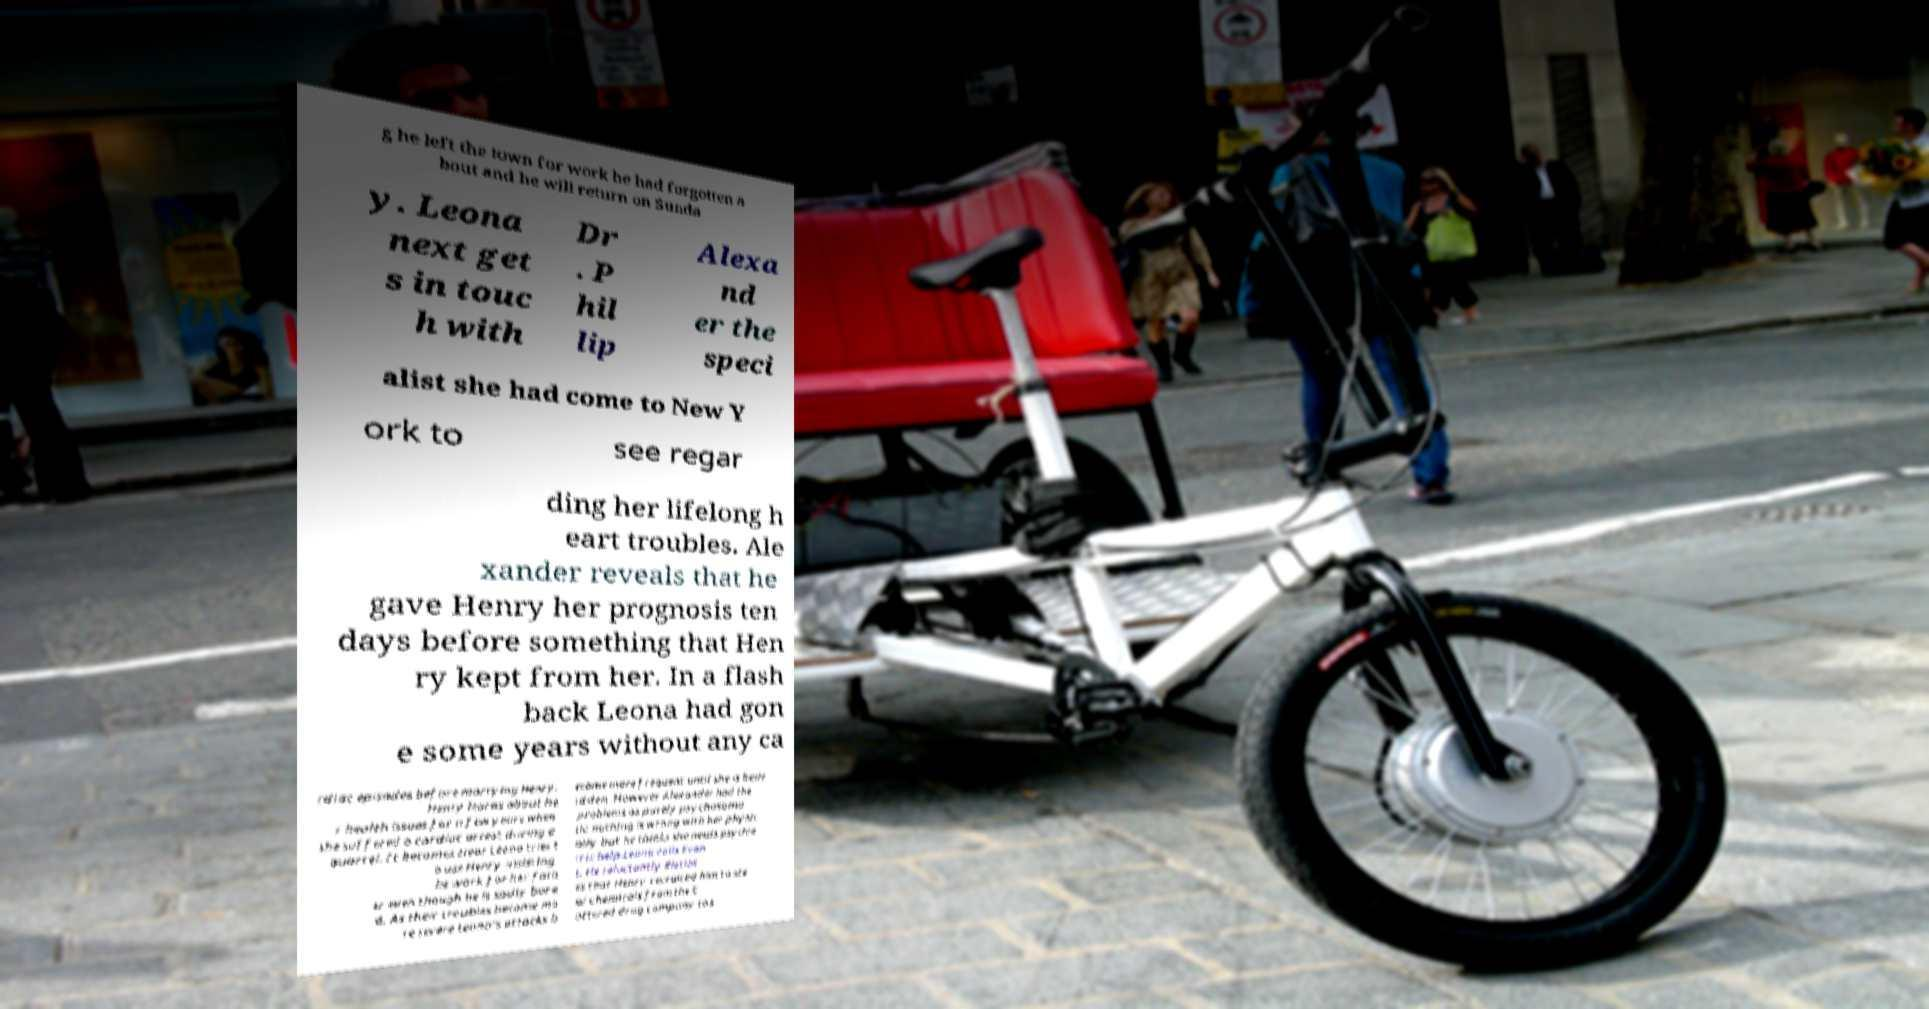Can you read and provide the text displayed in the image?This photo seems to have some interesting text. Can you extract and type it out for me? g he left the town for work he had forgotten a bout and he will return on Sunda y. Leona next get s in touc h with Dr . P hil lip Alexa nd er the speci alist she had come to New Y ork to see regar ding her lifelong h eart troubles. Ale xander reveals that he gave Henry her prognosis ten days before something that Hen ry kept from her. In a flash back Leona had gon e some years without any ca rdiac episodes before marrying Henry. Henry learns about he r health issues for a few years when she suffered a cardiac arrest during a quarrel. It becomes clear Leona tries t o use Henry insisting he work for her fath er even though he is sadly bore d. As their troubles become mo re severe Leona's attacks b ecame more frequent until she is bedr idden. However Alexander had the problems as purely psychosoma tic nothing is wrong with her physic ally but he thinks she needs psychia tric help.Leona calls Evan s. He reluctantly disclos es that Henry recruited him to ste al chemicals from the C otterell drug company to s 